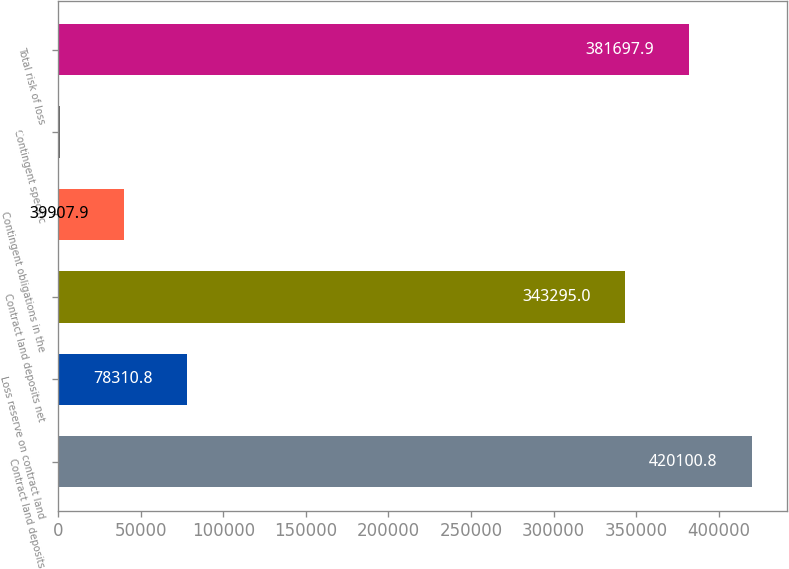Convert chart. <chart><loc_0><loc_0><loc_500><loc_500><bar_chart><fcel>Contract land deposits<fcel>Loss reserve on contract land<fcel>Contract land deposits net<fcel>Contingent obligations in the<fcel>Contingent specific<fcel>Total risk of loss<nl><fcel>420101<fcel>78310.8<fcel>343295<fcel>39907.9<fcel>1505<fcel>381698<nl></chart> 